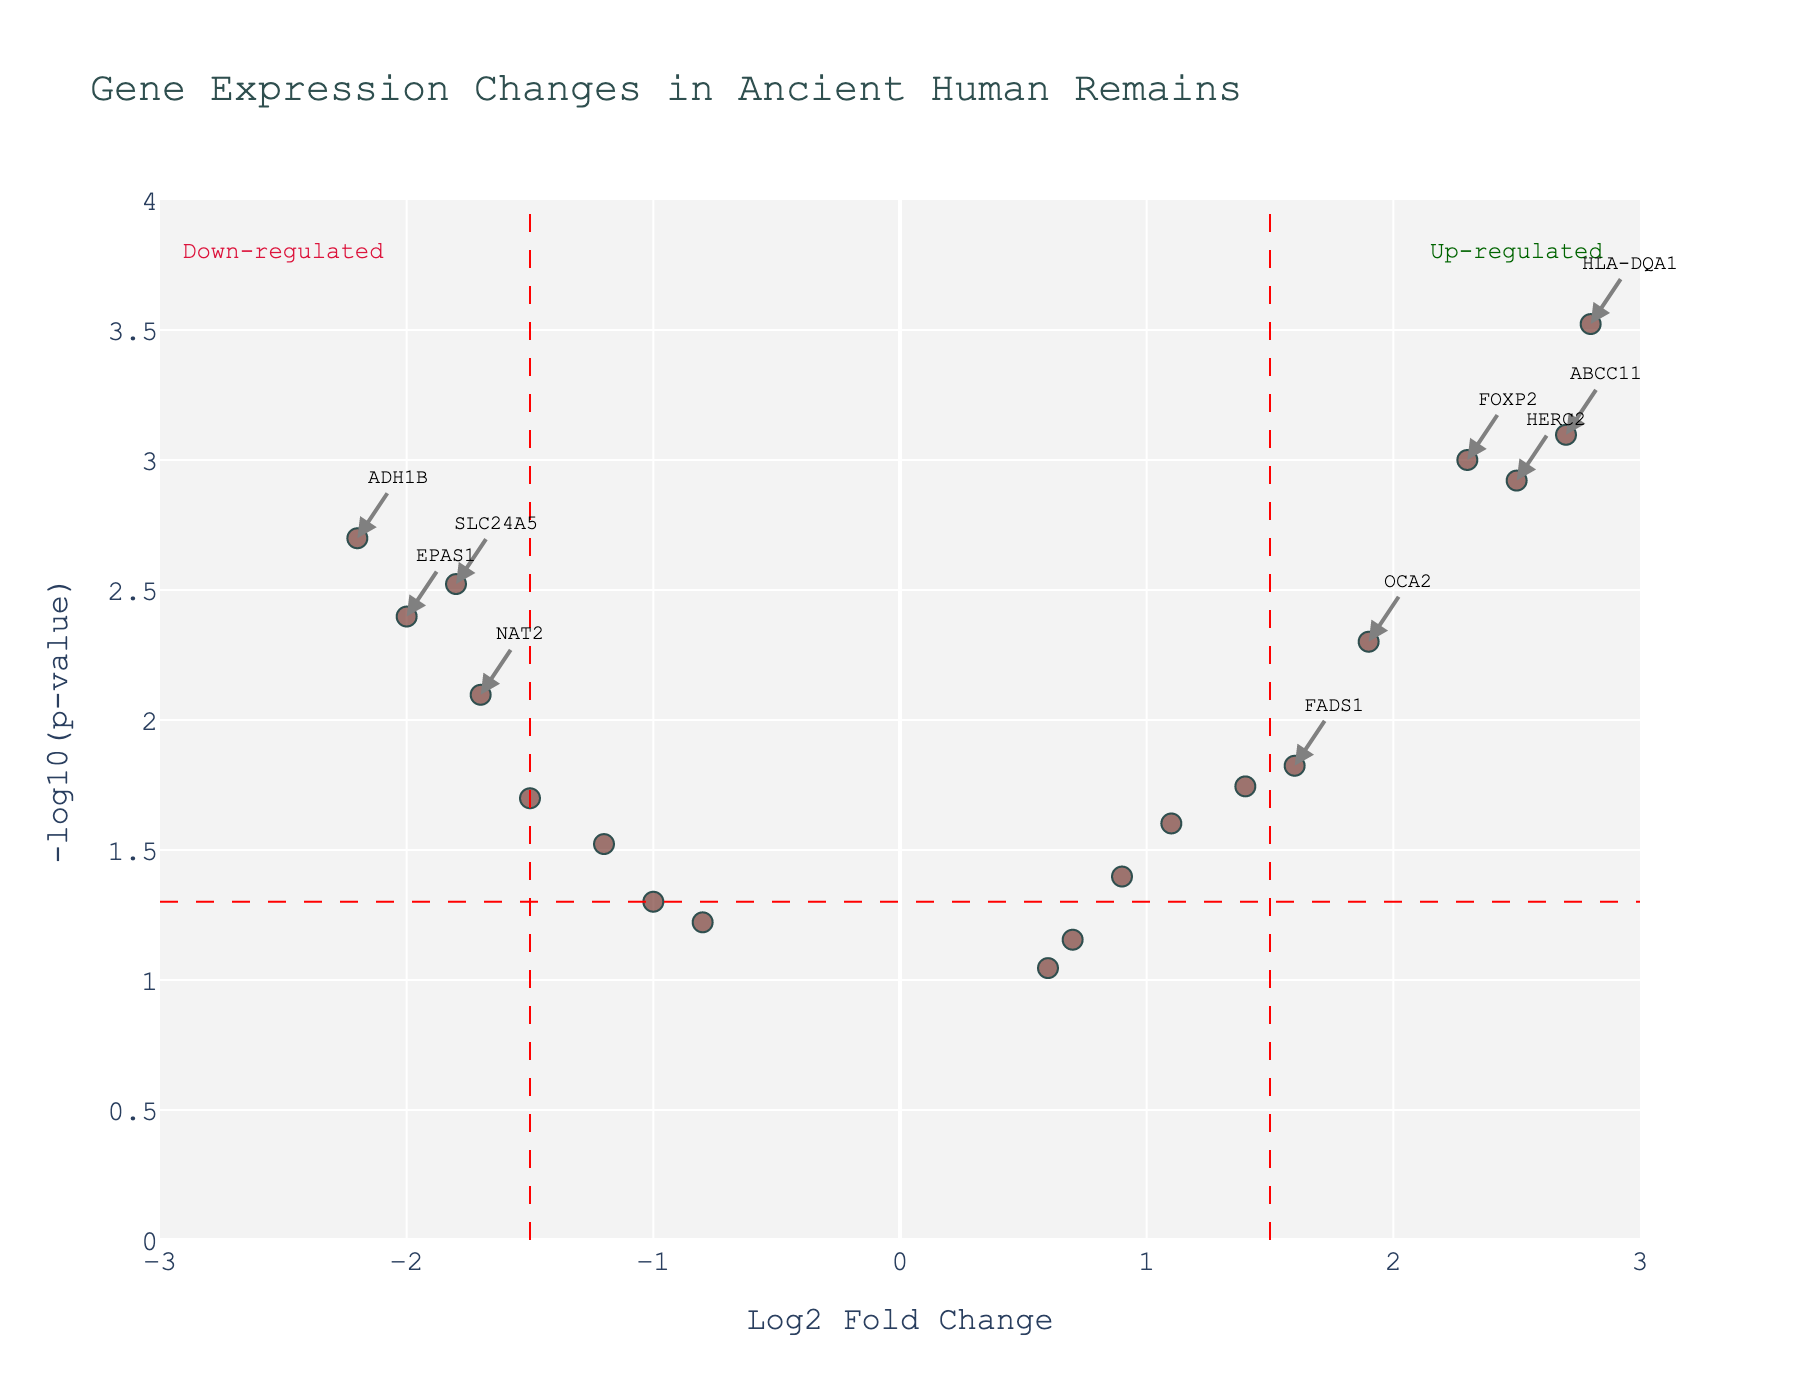what is the title of the figure? The title of the figure is typically found at the top of the plot. In this case, look at the top center of the figure where a descriptive text is written.
Answer: Gene Expression Changes in Ancient Human Remains What is on the x-axis of the plot? The x-axis of the plot is labeled "Log2 Fold Change," which indicates the logarithmic measure of the fold change in gene expression.
Answer: Log2 Fold Change What does the y-axis represent in the plot? The y-axis represents "-log10(p-value)," which is the negative base-10 logarithm of the p-value. This indicates the statistical significance of the gene expression changes.
Answer: -log10(p-value) How many genes are represented in this volcano plot? Count each data point in the plot, which represents a gene. The number of data points corresponds to the number of genes.
Answer: 20 Which gene has the highest -log10(p-value) and what is its value? Look for the data point that is highest on the y-axis and note the y-value. In this plot, the gene HLA-DQA1 has the highest -log10(p-value), corresponding to a value just above 3.5.
Answer: HLA-DQA1, just above 3.5 Which gene shows the highest up-regulation and what is its Log2 fold change? To find the highest up-regulated gene, look for the data point furthest to the right on the x-axis. The gene LCT has the highest up-regulation with a Log2 fold change of ~3.1.
Answer: LCT, ~3.1 Identify a gene that is significantly down-regulated and write its name and Log2 fold change. A significantly down-regulated gene will be farthest to the left and above the p-value threshold line. Here, the gene ADH1B fits that description with a Log2 fold change of around -2.2.
Answer: ADH1B, -2.2 Which genes are up-regulated and have a p-value less than 0.001? Look for genes that are on the right side of the Log2 fold change threshold (x > 1.5) and their corresponding p-value (y > -log10(0.001)), specifically genes like FOXP2, LCT, ABCC11, HLA-DQA1, and HERC2.
Answer: FOXP2, LCT, ABCC11, HLA-DQA1, HERC2 Compare the genes FOXP2 and TLR1 in terms of their Log2 fold change and -log10(p-value). Which one is more statistically significant? To determine statistical significance, compare their positions on the y-axis (higher is more significant). FOXP2 has a higher -log10(p-value) than TLR1, making it more statistically significant.
Answer: FOXP2 is more statistically significant Find a gene with a Log2 fold change between -1 and 1. What is its significance level? Locate a gene within the x-axis range of -1 to 1; TLR1 at ~0.7 fits this. The corresponding y-value gives the significance level. TLR1 has a -log10(p-value) slightly below 1, translating to a p-value just above 0.1.
Answer: TLR1, p > 0.1 